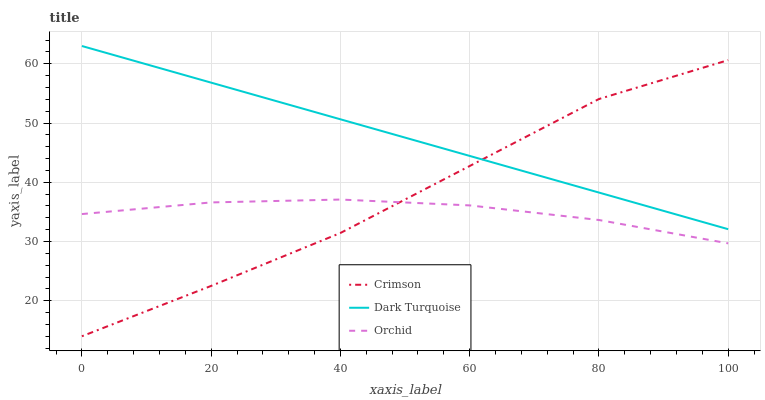Does Orchid have the minimum area under the curve?
Answer yes or no. Yes. Does Dark Turquoise have the maximum area under the curve?
Answer yes or no. Yes. Does Dark Turquoise have the minimum area under the curve?
Answer yes or no. No. Does Orchid have the maximum area under the curve?
Answer yes or no. No. Is Dark Turquoise the smoothest?
Answer yes or no. Yes. Is Crimson the roughest?
Answer yes or no. Yes. Is Orchid the smoothest?
Answer yes or no. No. Is Orchid the roughest?
Answer yes or no. No. Does Crimson have the lowest value?
Answer yes or no. Yes. Does Orchid have the lowest value?
Answer yes or no. No. Does Dark Turquoise have the highest value?
Answer yes or no. Yes. Does Orchid have the highest value?
Answer yes or no. No. Is Orchid less than Dark Turquoise?
Answer yes or no. Yes. Is Dark Turquoise greater than Orchid?
Answer yes or no. Yes. Does Orchid intersect Crimson?
Answer yes or no. Yes. Is Orchid less than Crimson?
Answer yes or no. No. Is Orchid greater than Crimson?
Answer yes or no. No. Does Orchid intersect Dark Turquoise?
Answer yes or no. No. 